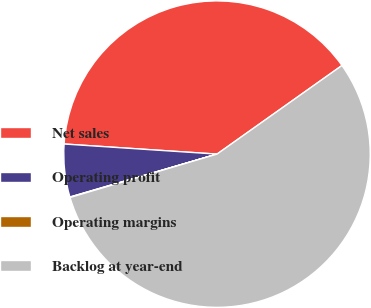<chart> <loc_0><loc_0><loc_500><loc_500><pie_chart><fcel>Net sales<fcel>Operating profit<fcel>Operating margins<fcel>Backlog at year-end<nl><fcel>39.13%<fcel>5.57%<fcel>0.05%<fcel>55.25%<nl></chart> 